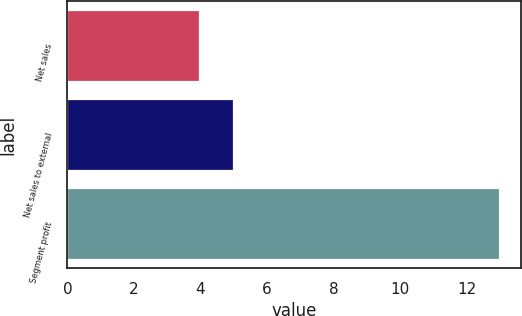Convert chart. <chart><loc_0><loc_0><loc_500><loc_500><bar_chart><fcel>Net sales<fcel>Net sales to external<fcel>Segment profit<nl><fcel>4<fcel>5<fcel>13<nl></chart> 